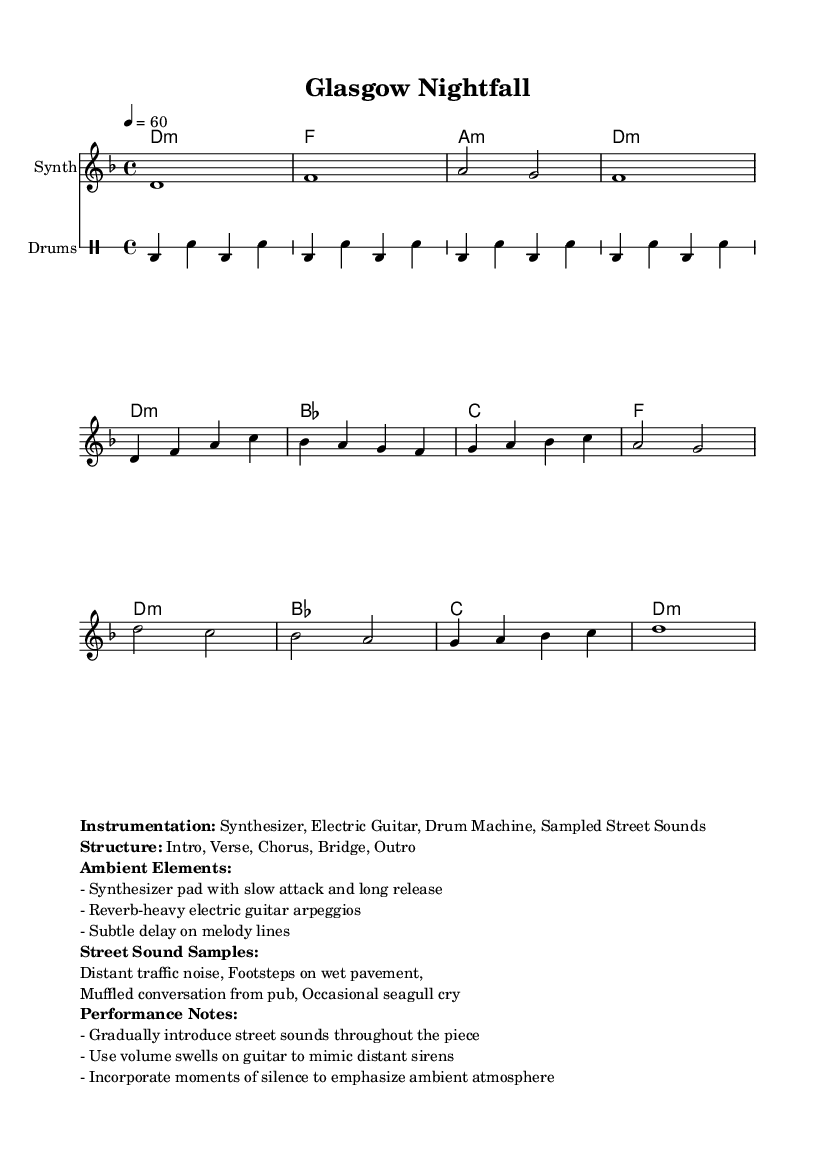What is the key signature of this music? The key signature is indicated at the beginning of the score, showing two flats, which corresponds to D minor.
Answer: D minor What is the time signature of this piece? The time signature is shown at the start of the score as 4/4, meaning there are four beats in a measure and a quarter note gets one beat.
Answer: 4/4 What is the tempo marking for this score? The tempo marking is indicated as "4 = 60", meaning the metronome is set to 60 beats per minute, which gives a slow, relaxed feel to the piece.
Answer: 60 How many sections are in the structure of this piece? The structure is outlined in the markup at the end of the code, which lists five sections: Intro, Verse, Chorus, Bridge, and Outro.
Answer: Five What type of instrument is primarily featured for the melody? The melody is written for the "Synth" which is specified in the staff notation section, indicating the primary instrument for melodic lines.
Answer: Synthesizer What ambient element is suggested for the guitar performance? The performance notes indicate a "reverb-heavy" quality for the electric guitar arpeggios, enhancing the ambient texture of the piece.
Answer: Reverb-heavy What sound samples are suggested to be included during the performance? The performance notes include several street sounds that should be sampled, such as "Distant traffic noise" and "Footsteps on wet pavement," which contribute to the piece's atmospheric quality.
Answer: Distant traffic noise, Footsteps on wet pavement 